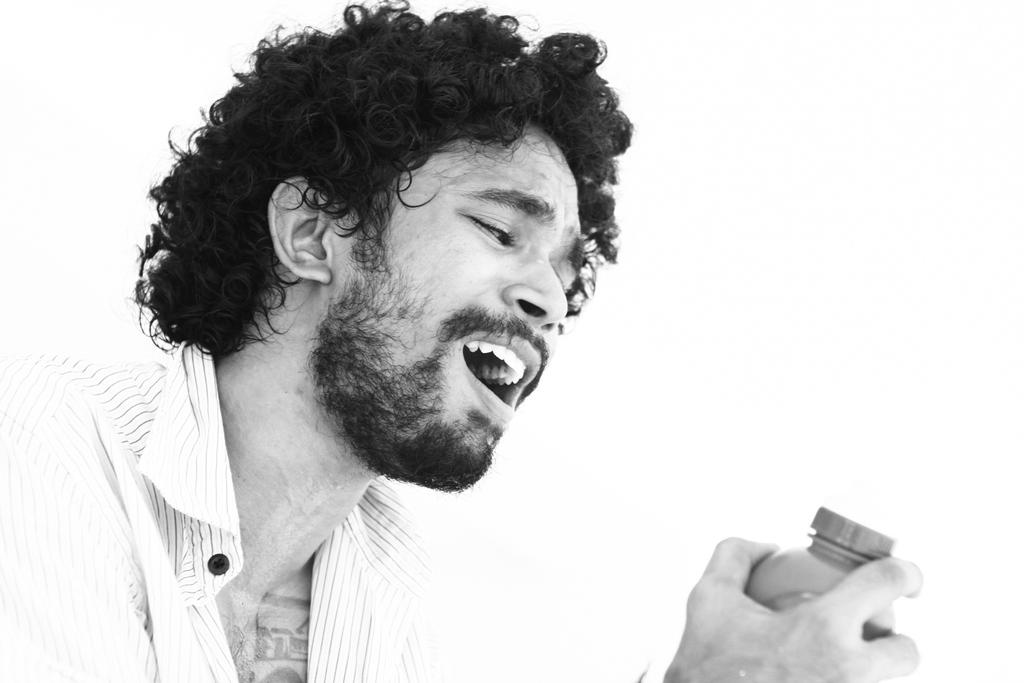Who is present in the image? There is a man in the image. What is the man wearing? The man is wearing a shirt. What is the man holding in the image? The man is holding a bottle. What color is the background of the image? The background of the image is white. How many bikes are parked next to the man in the image? There are no bikes present in the image. What type of form does the rat in the image have? There is no rat present in the image. 